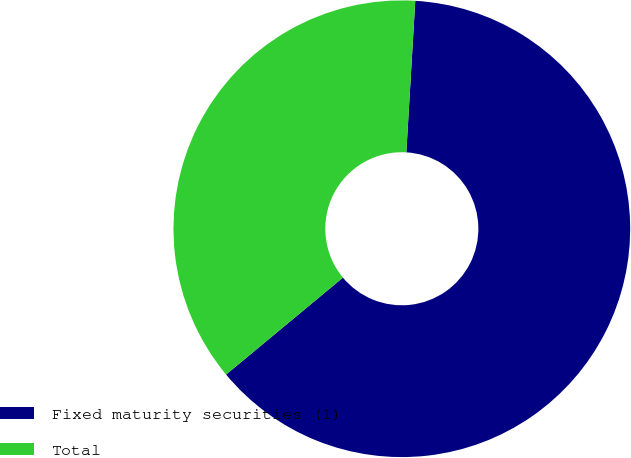Convert chart. <chart><loc_0><loc_0><loc_500><loc_500><pie_chart><fcel>Fixed maturity securities (1)<fcel>Total<nl><fcel>63.04%<fcel>36.96%<nl></chart> 